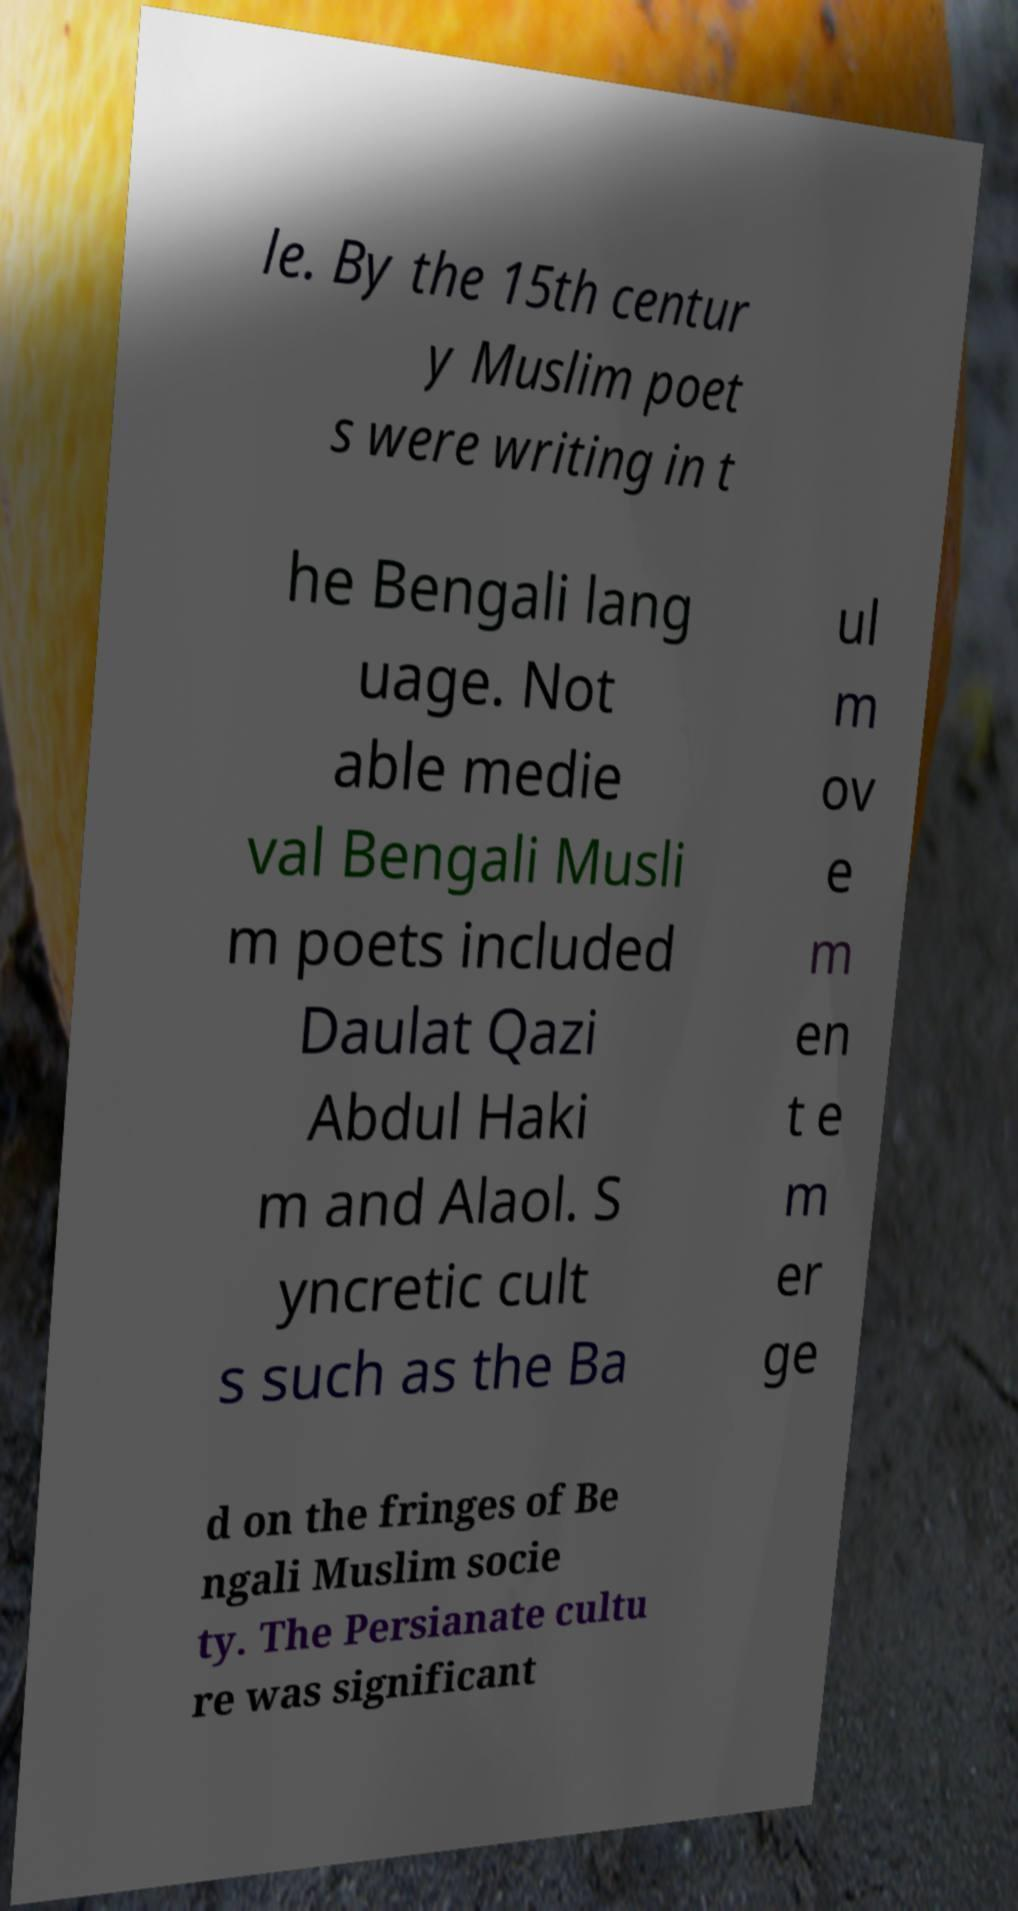Can you read and provide the text displayed in the image?This photo seems to have some interesting text. Can you extract and type it out for me? le. By the 15th centur y Muslim poet s were writing in t he Bengali lang uage. Not able medie val Bengali Musli m poets included Daulat Qazi Abdul Haki m and Alaol. S yncretic cult s such as the Ba ul m ov e m en t e m er ge d on the fringes of Be ngali Muslim socie ty. The Persianate cultu re was significant 